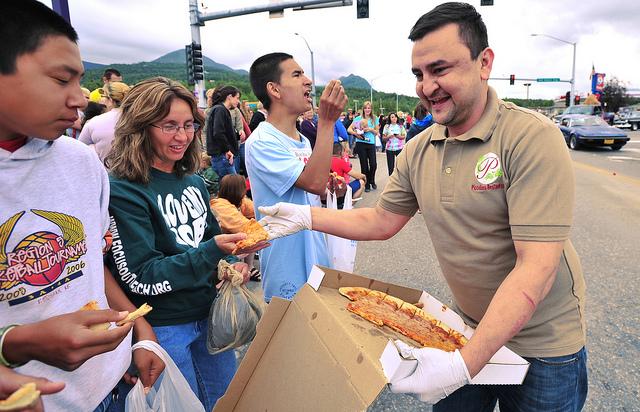Is the pizza on a plate?
Answer briefly. No. Does the man have eyeglasses on his shirt?
Give a very brief answer. No. Is the man who is handing out pizza wearing gloves?
Write a very short answer. Yes. Is this taking place in an urban environment?
Concise answer only. No. Does this man enjoy street food?
Quick response, please. Yes. What food is the man passing out?
Answer briefly. Pizza. 